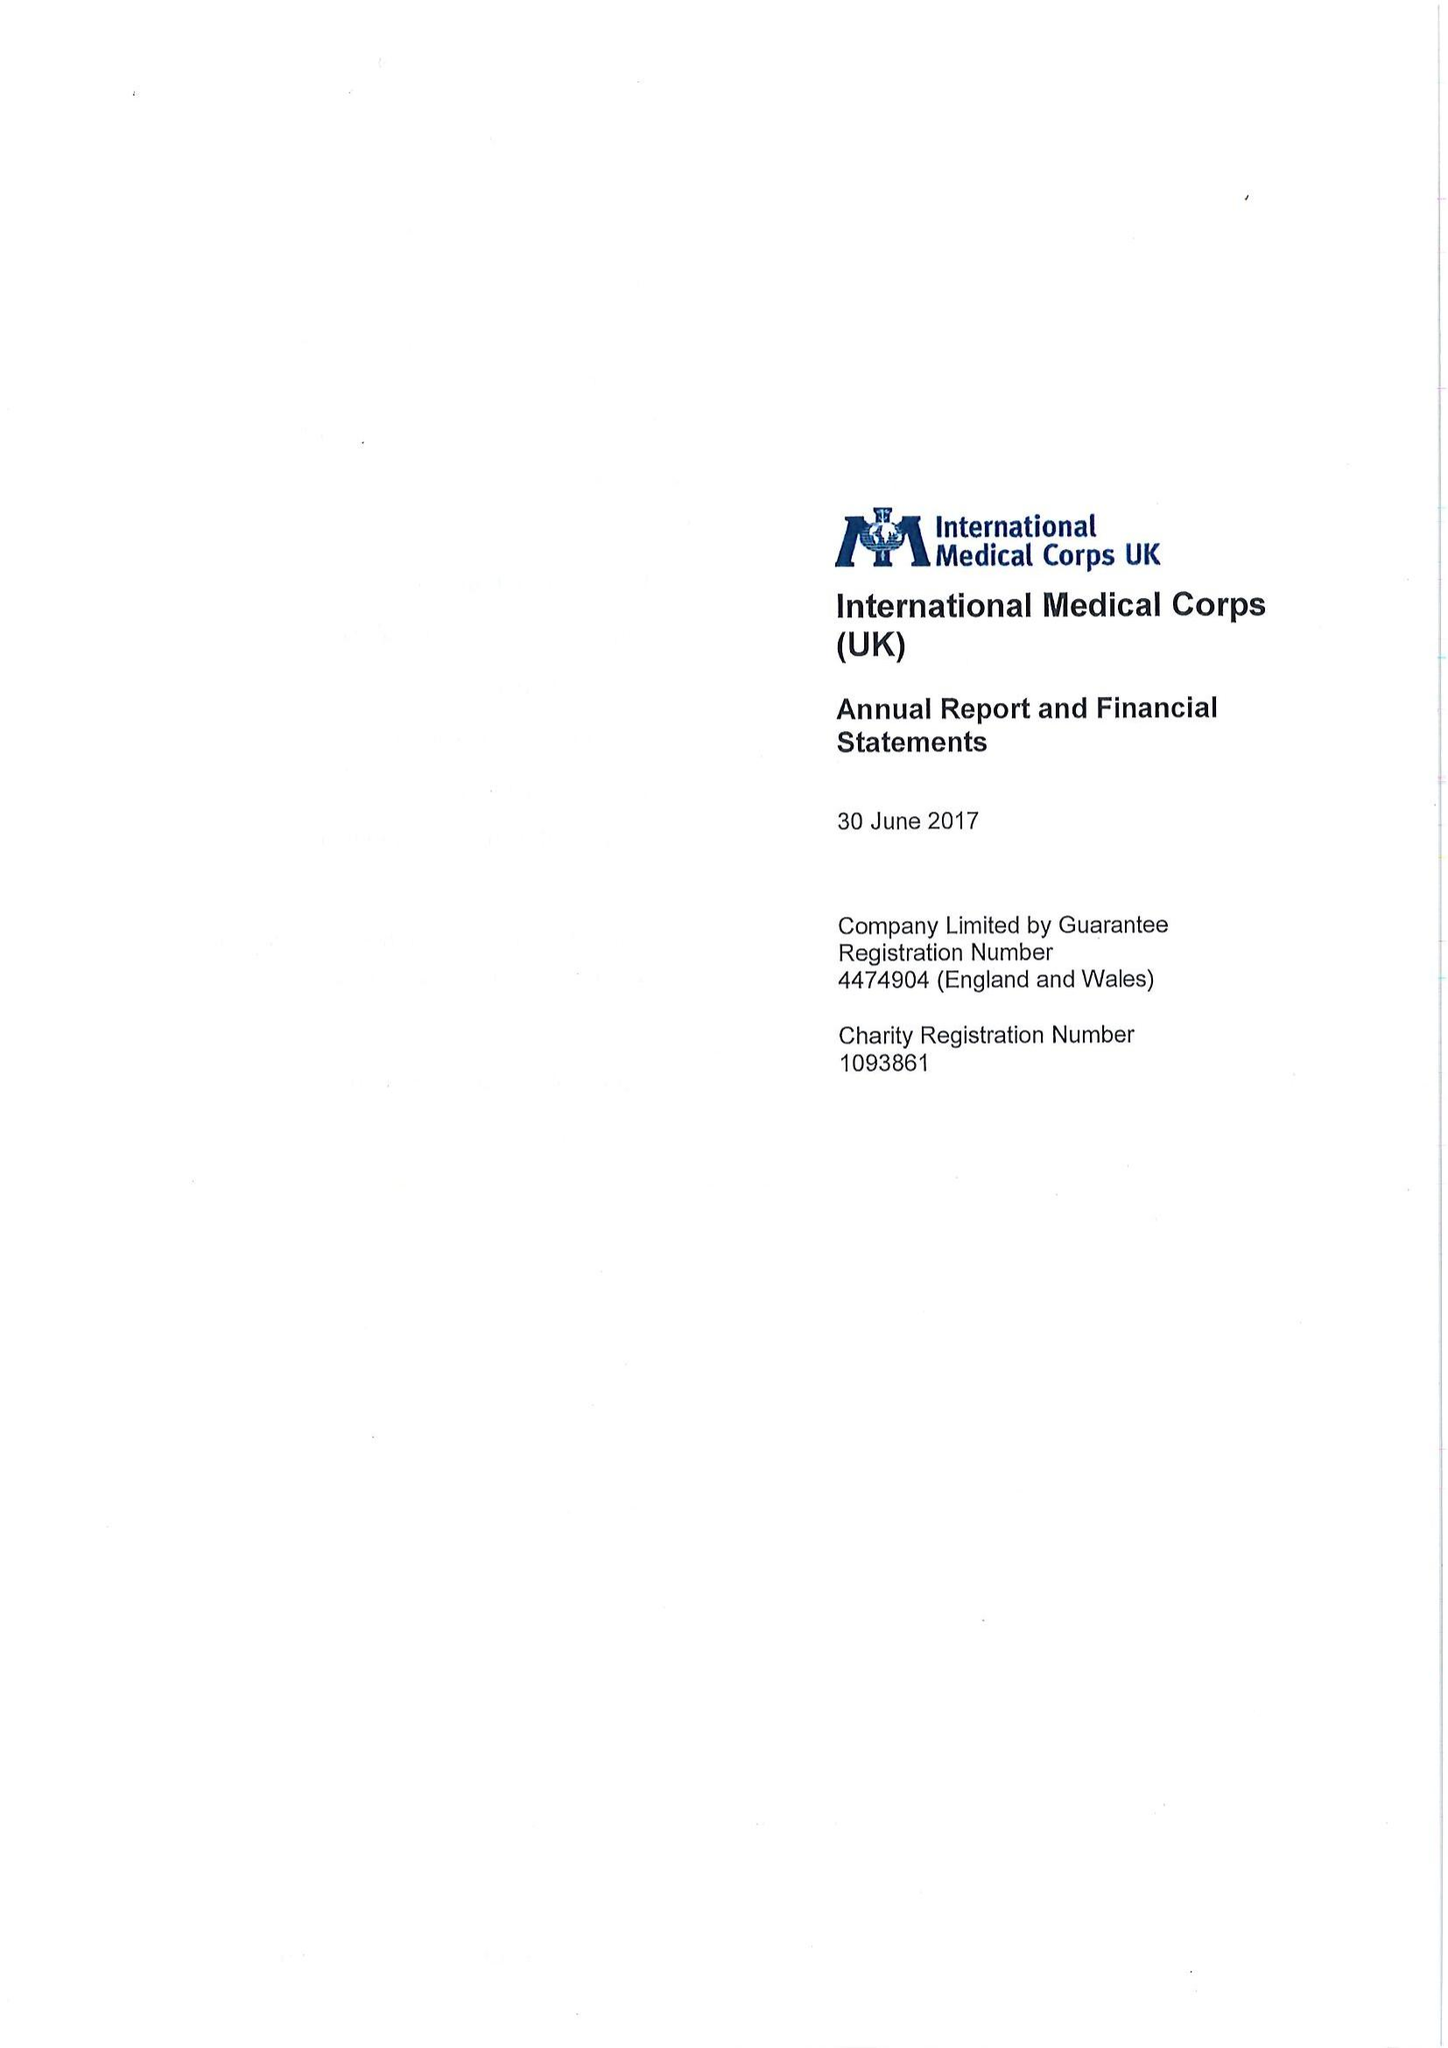What is the value for the charity_number?
Answer the question using a single word or phrase. 1093861 